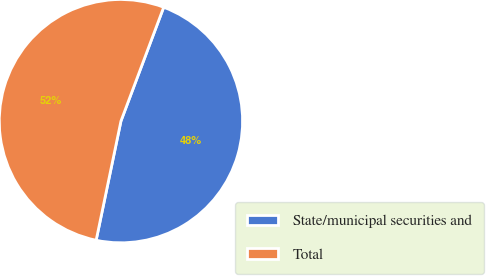Convert chart. <chart><loc_0><loc_0><loc_500><loc_500><pie_chart><fcel>State/municipal securities and<fcel>Total<nl><fcel>47.55%<fcel>52.45%<nl></chart> 